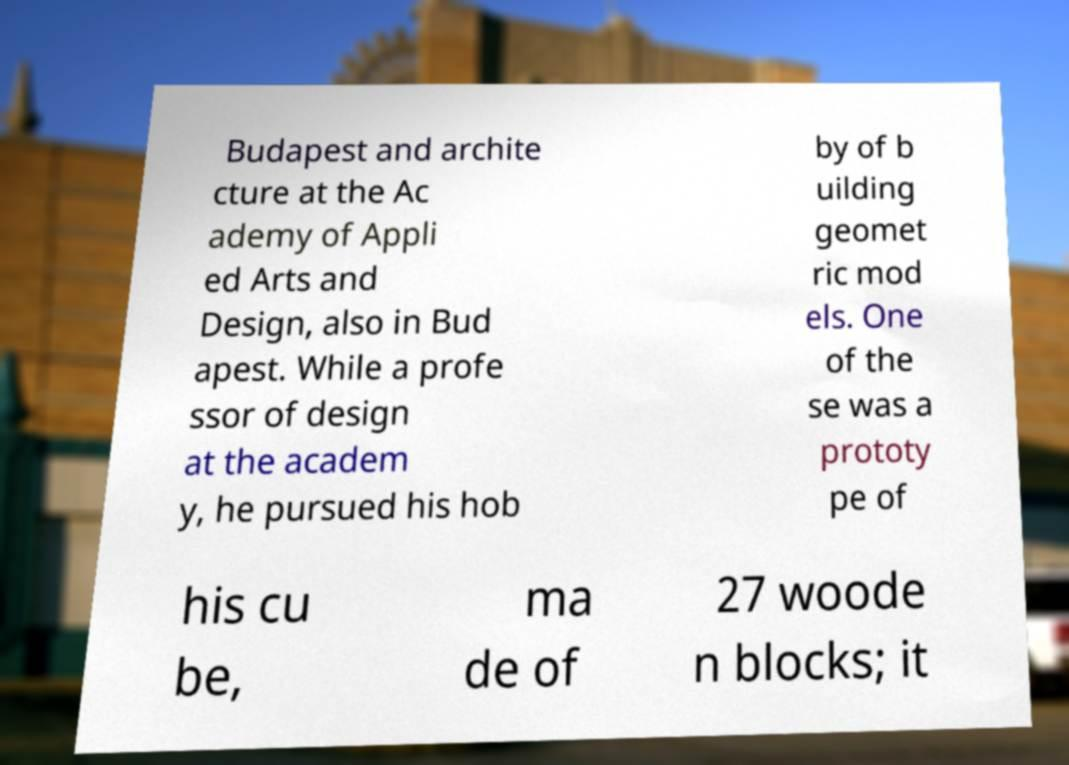I need the written content from this picture converted into text. Can you do that? Budapest and archite cture at the Ac ademy of Appli ed Arts and Design, also in Bud apest. While a profe ssor of design at the academ y, he pursued his hob by of b uilding geomet ric mod els. One of the se was a prototy pe of his cu be, ma de of 27 woode n blocks; it 